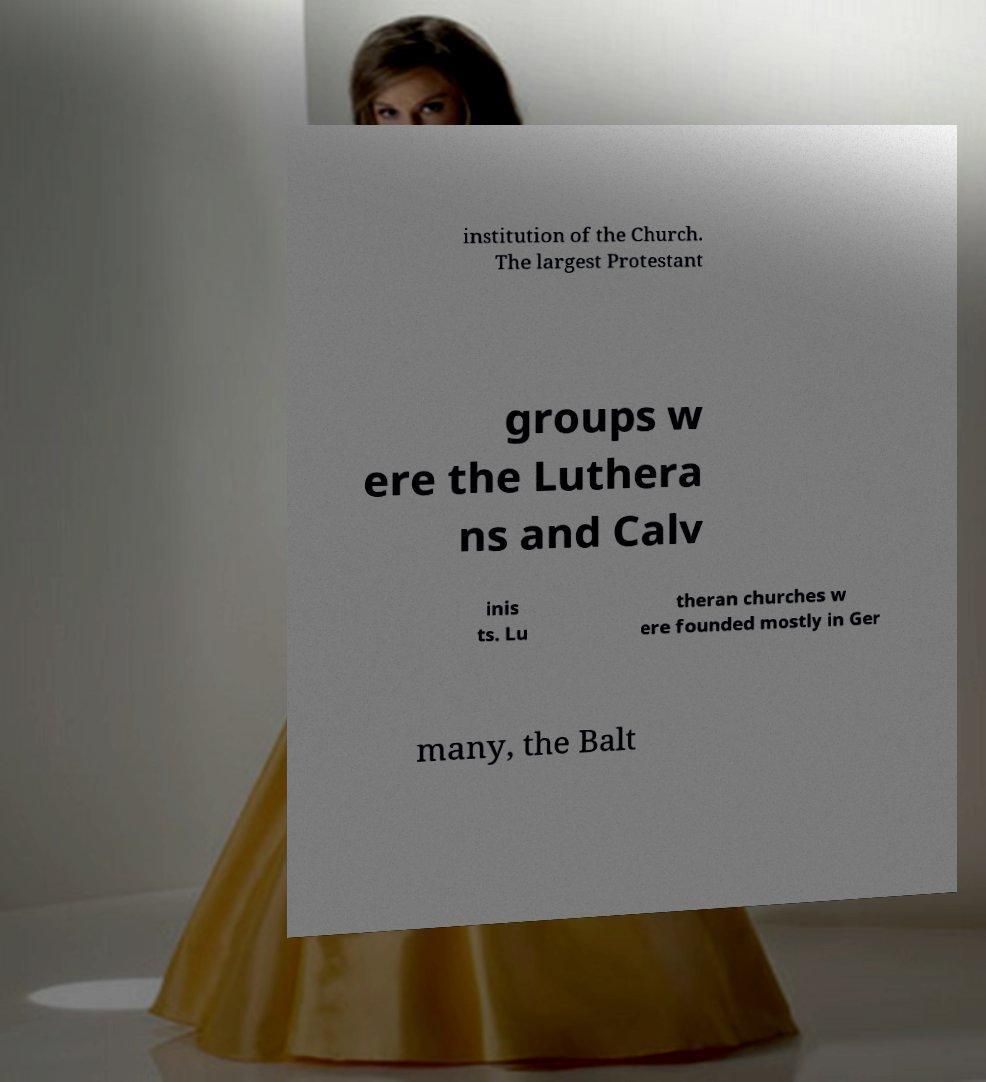Can you accurately transcribe the text from the provided image for me? institution of the Church. The largest Protestant groups w ere the Luthera ns and Calv inis ts. Lu theran churches w ere founded mostly in Ger many, the Balt 